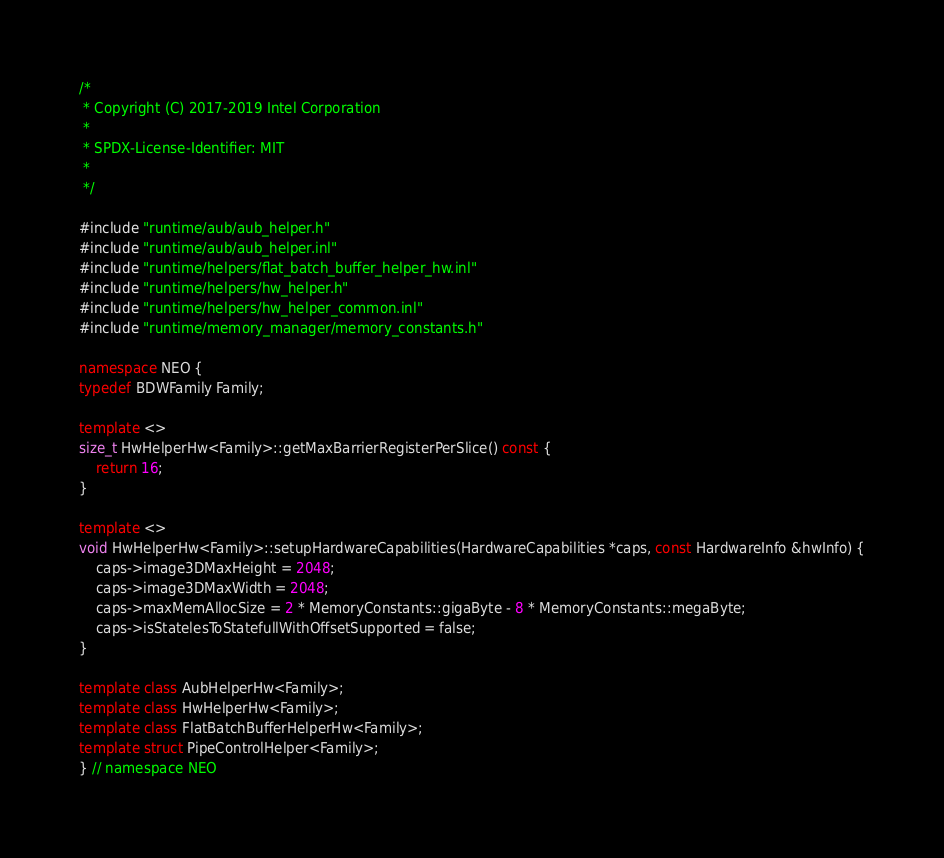Convert code to text. <code><loc_0><loc_0><loc_500><loc_500><_C++_>/*
 * Copyright (C) 2017-2019 Intel Corporation
 *
 * SPDX-License-Identifier: MIT
 *
 */

#include "runtime/aub/aub_helper.h"
#include "runtime/aub/aub_helper.inl"
#include "runtime/helpers/flat_batch_buffer_helper_hw.inl"
#include "runtime/helpers/hw_helper.h"
#include "runtime/helpers/hw_helper_common.inl"
#include "runtime/memory_manager/memory_constants.h"

namespace NEO {
typedef BDWFamily Family;

template <>
size_t HwHelperHw<Family>::getMaxBarrierRegisterPerSlice() const {
    return 16;
}

template <>
void HwHelperHw<Family>::setupHardwareCapabilities(HardwareCapabilities *caps, const HardwareInfo &hwInfo) {
    caps->image3DMaxHeight = 2048;
    caps->image3DMaxWidth = 2048;
    caps->maxMemAllocSize = 2 * MemoryConstants::gigaByte - 8 * MemoryConstants::megaByte;
    caps->isStatelesToStatefullWithOffsetSupported = false;
}

template class AubHelperHw<Family>;
template class HwHelperHw<Family>;
template class FlatBatchBufferHelperHw<Family>;
template struct PipeControlHelper<Family>;
} // namespace NEO
</code> 